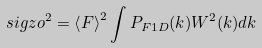<formula> <loc_0><loc_0><loc_500><loc_500>\ s i g z o ^ { 2 } = \left < F \right > ^ { 2 } \int P _ { F 1 D } ( k ) W ^ { 2 } ( k ) d k</formula> 